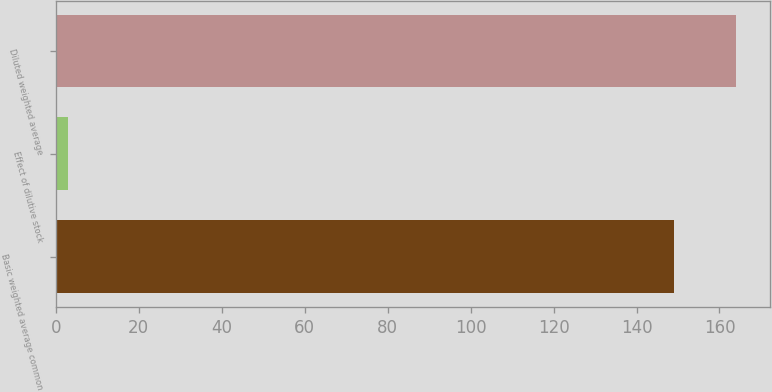Convert chart. <chart><loc_0><loc_0><loc_500><loc_500><bar_chart><fcel>Basic weighted average common<fcel>Effect of dilutive stock<fcel>Diluted weighted average<nl><fcel>149.1<fcel>2.9<fcel>164.01<nl></chart> 